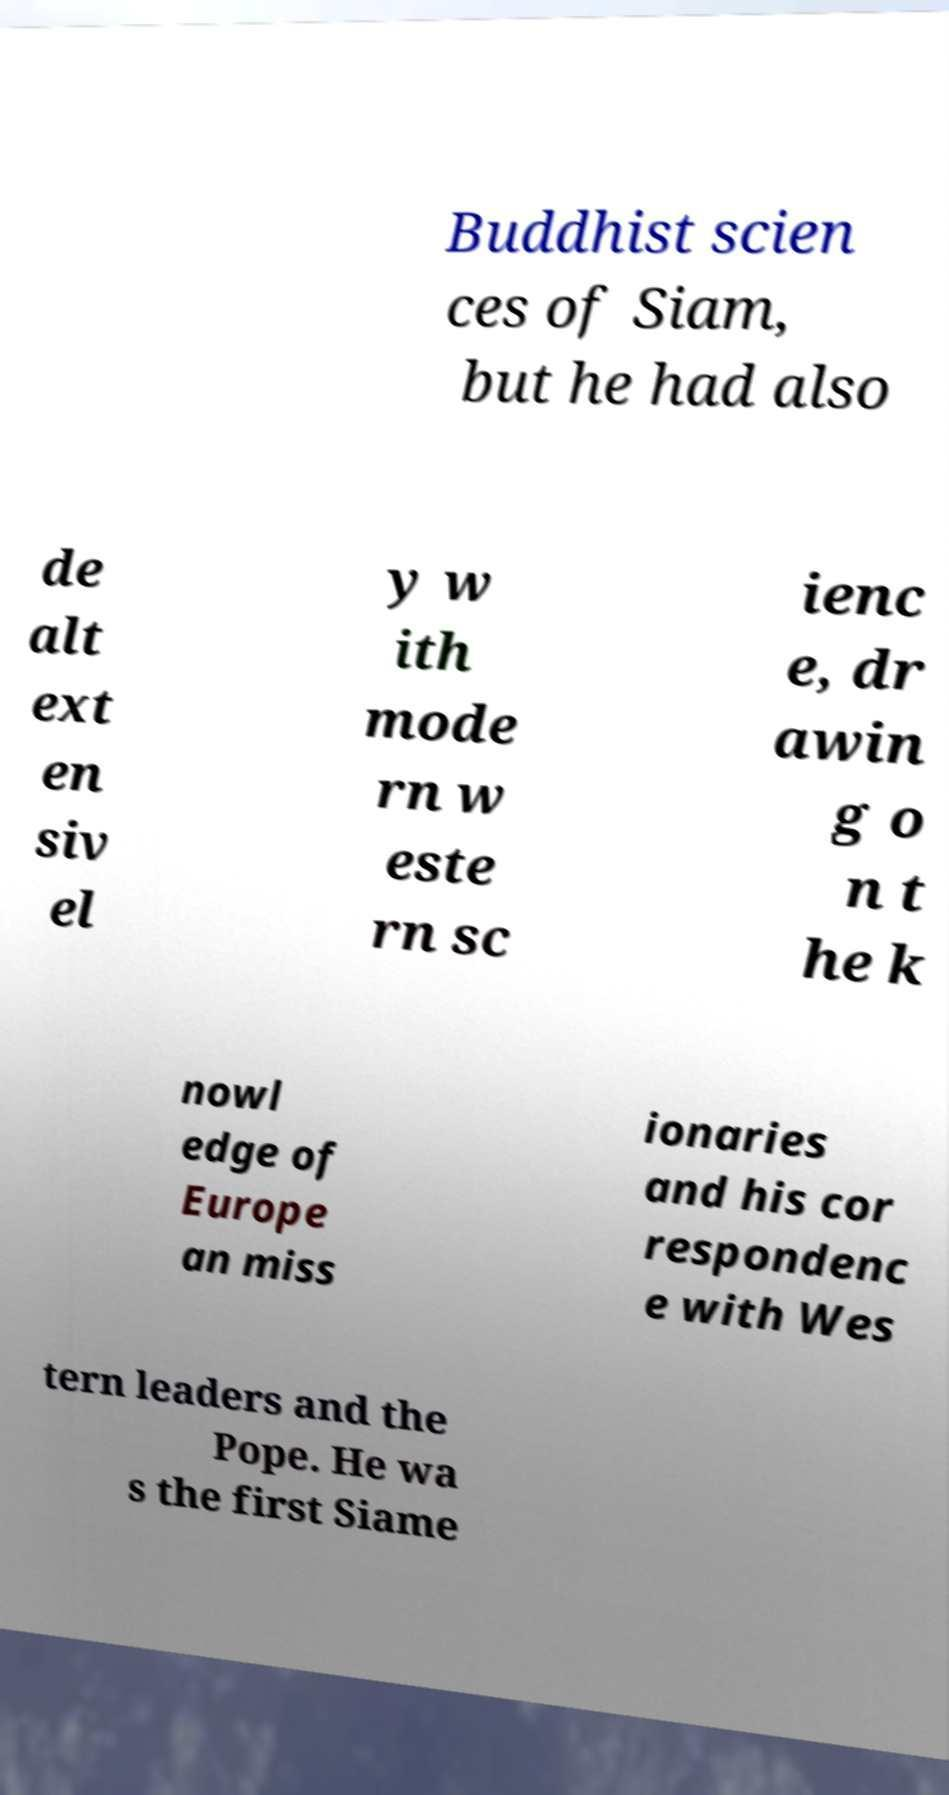Can you accurately transcribe the text from the provided image for me? Buddhist scien ces of Siam, but he had also de alt ext en siv el y w ith mode rn w este rn sc ienc e, dr awin g o n t he k nowl edge of Europe an miss ionaries and his cor respondenc e with Wes tern leaders and the Pope. He wa s the first Siame 